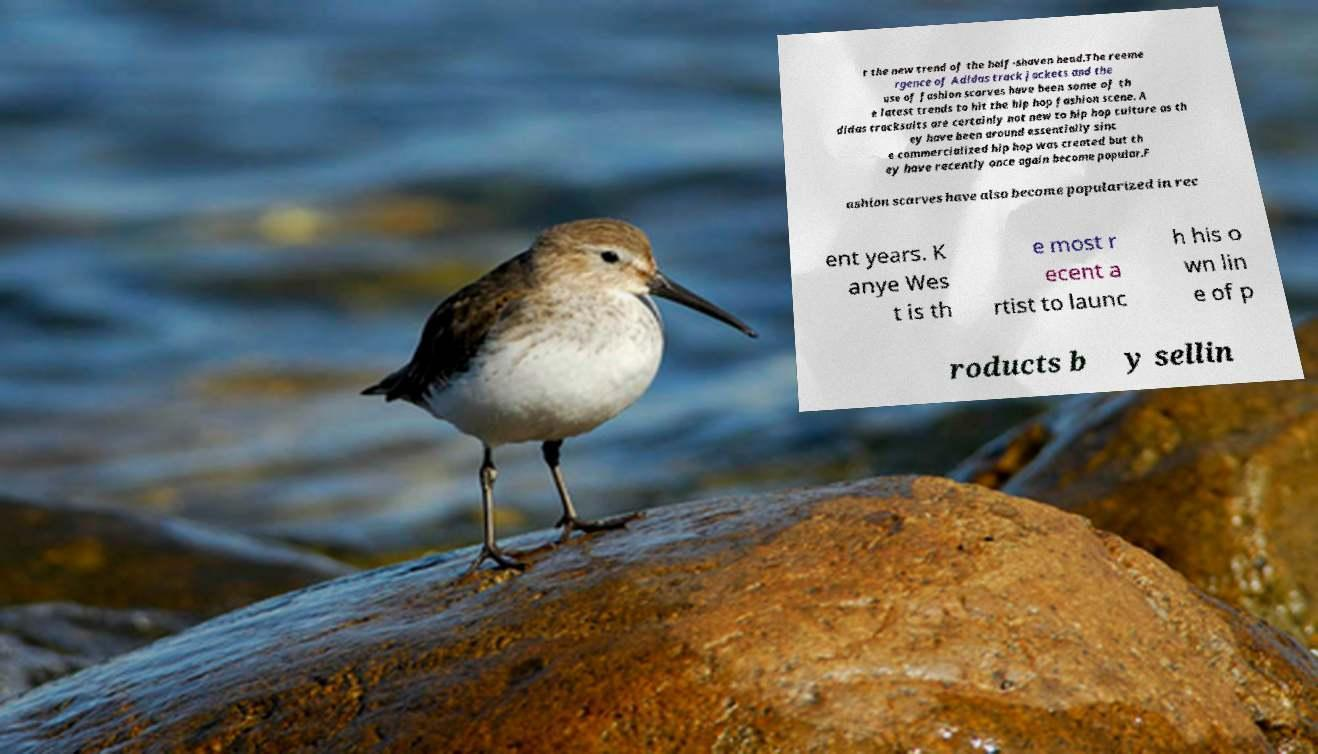Please read and relay the text visible in this image. What does it say? t the new trend of the half-shaven head.The reeme rgence of Adidas track jackets and the use of fashion scarves have been some of th e latest trends to hit the hip hop fashion scene. A didas tracksuits are certainly not new to hip hop culture as th ey have been around essentially sinc e commercialized hip hop was created but th ey have recently once again become popular.F ashion scarves have also become popularized in rec ent years. K anye Wes t is th e most r ecent a rtist to launc h his o wn lin e of p roducts b y sellin 